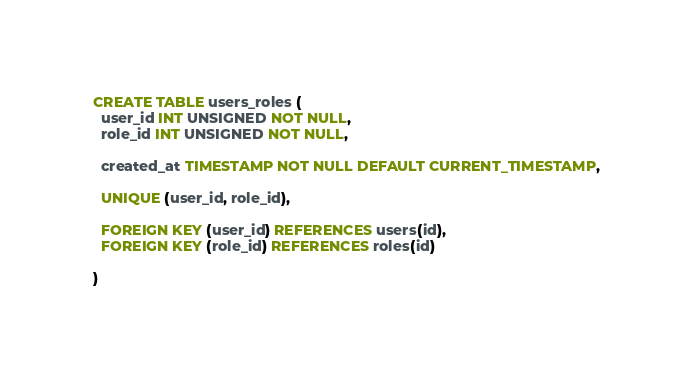Convert code to text. <code><loc_0><loc_0><loc_500><loc_500><_SQL_>CREATE TABLE users_roles (
  user_id INT UNSIGNED NOT NULL,
  role_id INT UNSIGNED NOT NULL,

  created_at TIMESTAMP NOT NULL DEFAULT CURRENT_TIMESTAMP,

  UNIQUE (user_id, role_id),

  FOREIGN KEY (user_id) REFERENCES users(id),
  FOREIGN KEY (role_id) REFERENCES roles(id)

)</code> 